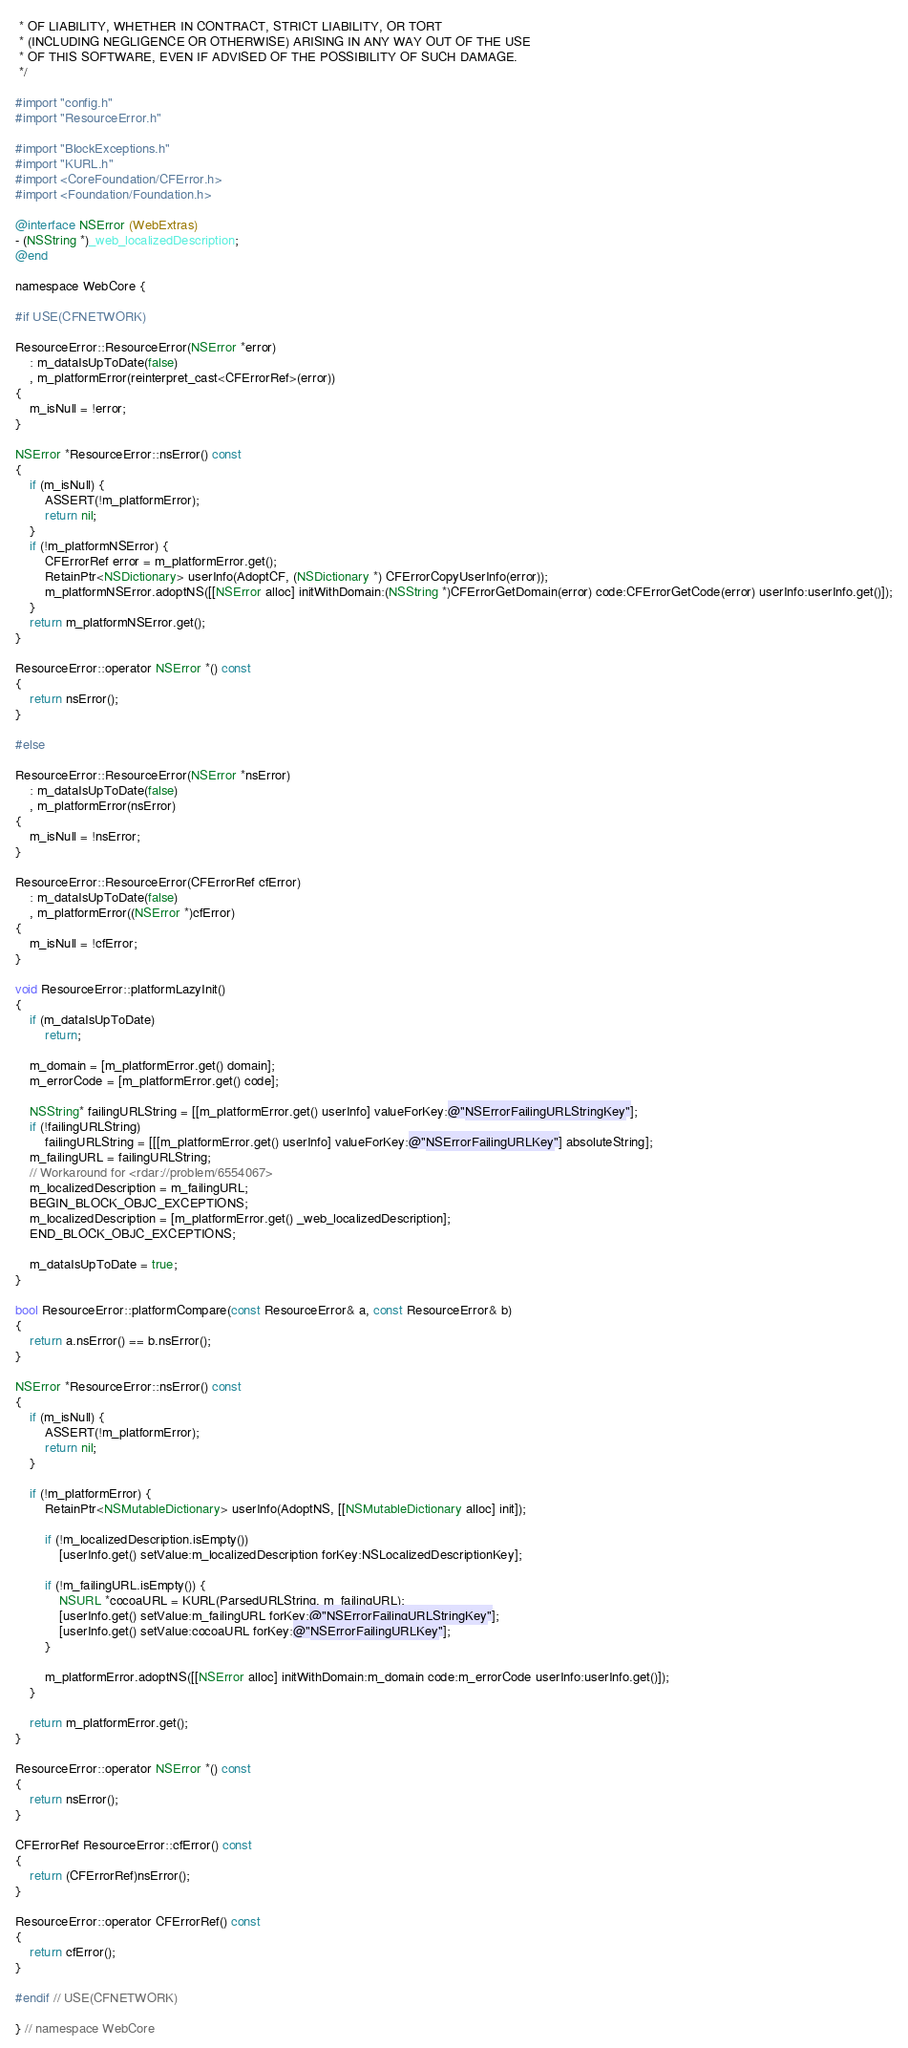<code> <loc_0><loc_0><loc_500><loc_500><_ObjectiveC_> * OF LIABILITY, WHETHER IN CONTRACT, STRICT LIABILITY, OR TORT
 * (INCLUDING NEGLIGENCE OR OTHERWISE) ARISING IN ANY WAY OUT OF THE USE
 * OF THIS SOFTWARE, EVEN IF ADVISED OF THE POSSIBILITY OF SUCH DAMAGE. 
 */

#import "config.h"
#import "ResourceError.h"

#import "BlockExceptions.h"
#import "KURL.h"
#import <CoreFoundation/CFError.h>
#import <Foundation/Foundation.h>

@interface NSError (WebExtras)
- (NSString *)_web_localizedDescription;
@end

namespace WebCore {

#if USE(CFNETWORK)

ResourceError::ResourceError(NSError *error)
    : m_dataIsUpToDate(false)
    , m_platformError(reinterpret_cast<CFErrorRef>(error))
{
    m_isNull = !error;
}

NSError *ResourceError::nsError() const
{
    if (m_isNull) {
        ASSERT(!m_platformError);
        return nil;
    }
    if (!m_platformNSError) {
        CFErrorRef error = m_platformError.get();
        RetainPtr<NSDictionary> userInfo(AdoptCF, (NSDictionary *) CFErrorCopyUserInfo(error));
        m_platformNSError.adoptNS([[NSError alloc] initWithDomain:(NSString *)CFErrorGetDomain(error) code:CFErrorGetCode(error) userInfo:userInfo.get()]);
    }
    return m_platformNSError.get();
}

ResourceError::operator NSError *() const
{
    return nsError();
}

#else

ResourceError::ResourceError(NSError *nsError)
    : m_dataIsUpToDate(false)
    , m_platformError(nsError)
{
    m_isNull = !nsError;
}

ResourceError::ResourceError(CFErrorRef cfError)
    : m_dataIsUpToDate(false)
    , m_platformError((NSError *)cfError)
{
    m_isNull = !cfError;
}

void ResourceError::platformLazyInit()
{
    if (m_dataIsUpToDate)
        return;

    m_domain = [m_platformError.get() domain];
    m_errorCode = [m_platformError.get() code];

    NSString* failingURLString = [[m_platformError.get() userInfo] valueForKey:@"NSErrorFailingURLStringKey"];
    if (!failingURLString)
        failingURLString = [[[m_platformError.get() userInfo] valueForKey:@"NSErrorFailingURLKey"] absoluteString];
    m_failingURL = failingURLString; 
    // Workaround for <rdar://problem/6554067>
    m_localizedDescription = m_failingURL;
    BEGIN_BLOCK_OBJC_EXCEPTIONS;
    m_localizedDescription = [m_platformError.get() _web_localizedDescription];
    END_BLOCK_OBJC_EXCEPTIONS;

    m_dataIsUpToDate = true;
}

bool ResourceError::platformCompare(const ResourceError& a, const ResourceError& b)
{
    return a.nsError() == b.nsError();
}

NSError *ResourceError::nsError() const
{
    if (m_isNull) {
        ASSERT(!m_platformError);
        return nil;
    }
    
    if (!m_platformError) {
        RetainPtr<NSMutableDictionary> userInfo(AdoptNS, [[NSMutableDictionary alloc] init]);

        if (!m_localizedDescription.isEmpty())
            [userInfo.get() setValue:m_localizedDescription forKey:NSLocalizedDescriptionKey];

        if (!m_failingURL.isEmpty()) {
            NSURL *cocoaURL = KURL(ParsedURLString, m_failingURL);
            [userInfo.get() setValue:m_failingURL forKey:@"NSErrorFailingURLStringKey"];
            [userInfo.get() setValue:cocoaURL forKey:@"NSErrorFailingURLKey"];
        }

        m_platformError.adoptNS([[NSError alloc] initWithDomain:m_domain code:m_errorCode userInfo:userInfo.get()]);
    }

    return m_platformError.get();
}

ResourceError::operator NSError *() const
{
    return nsError();
}

CFErrorRef ResourceError::cfError() const
{
    return (CFErrorRef)nsError();
}

ResourceError::operator CFErrorRef() const
{
    return cfError();
}

#endif // USE(CFNETWORK)

} // namespace WebCore
</code> 